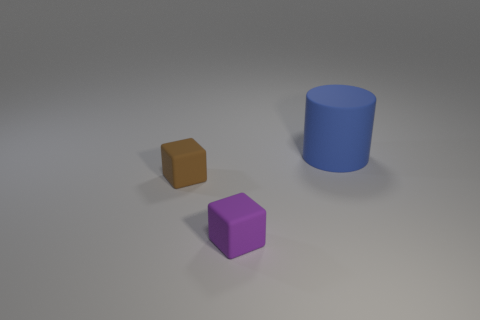Add 3 blue matte cylinders. How many objects exist? 6 Subtract 1 cylinders. How many cylinders are left? 0 Subtract all brown cubes. How many cubes are left? 1 Subtract all large green metallic cubes. Subtract all small brown rubber objects. How many objects are left? 2 Add 2 small purple matte things. How many small purple matte things are left? 3 Add 2 large blue rubber blocks. How many large blue rubber blocks exist? 2 Subtract 0 blue cubes. How many objects are left? 3 Subtract all blocks. How many objects are left? 1 Subtract all yellow cubes. Subtract all cyan balls. How many cubes are left? 2 